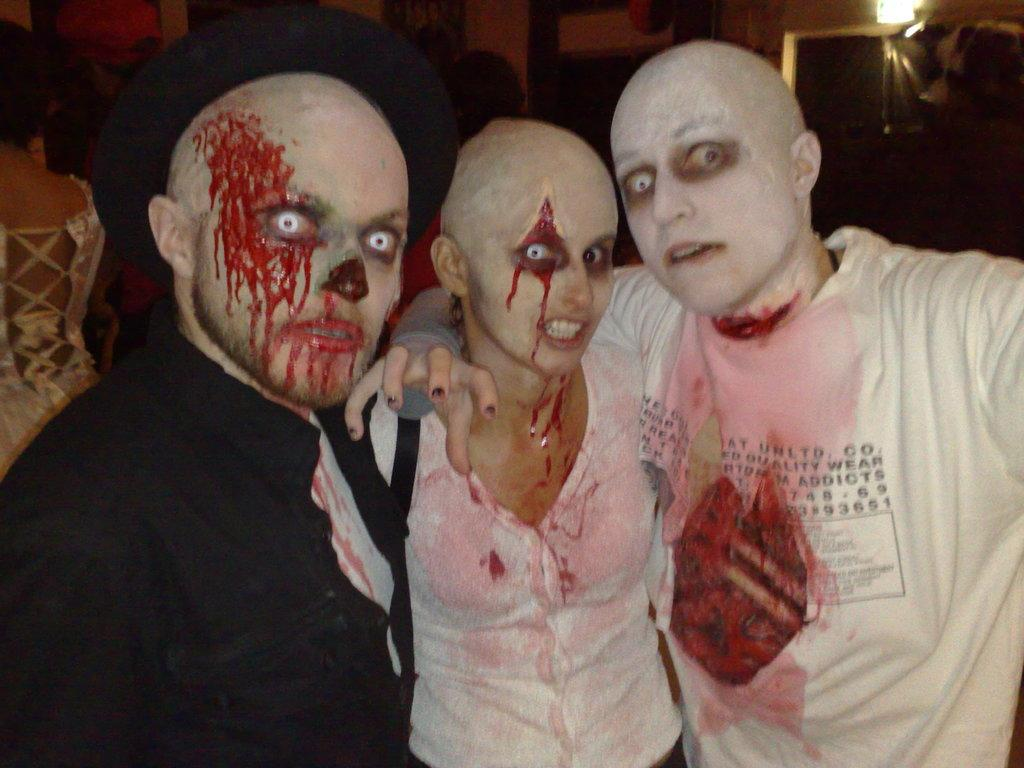Who or what can be seen in the image? There are people in the image. What is notable about the appearance of the people? The people have hallowed makeups. What else can be observed about the people in the image? The people are wearing costumes. What type of alarm is going off in the image? There is no alarm present in the image. What type of skirt is the person wearing in the image? There is no skirt visible in the image, as the people are wearing costumes. 